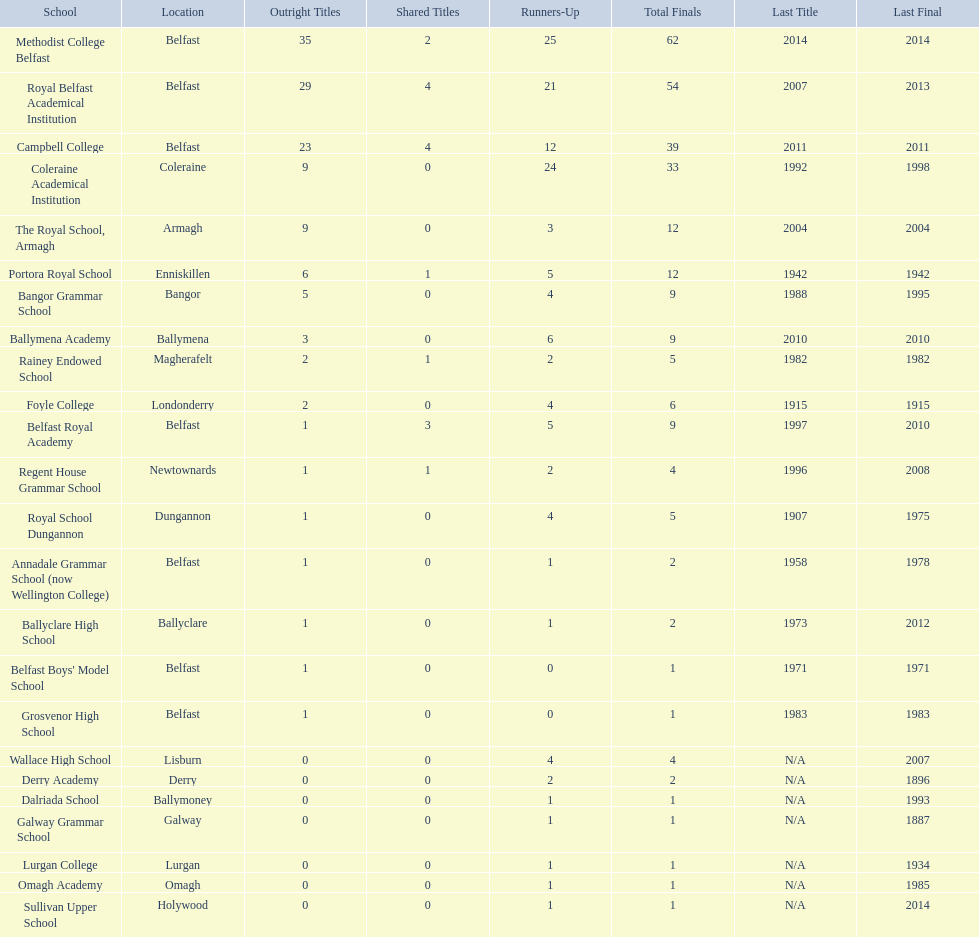What is the last achievement of campbell college? 2011. What is the last achievement of regent house grammar school? 1996. Which of these instances is newer? 2011. Which school has this more recent date? Campbell College. 